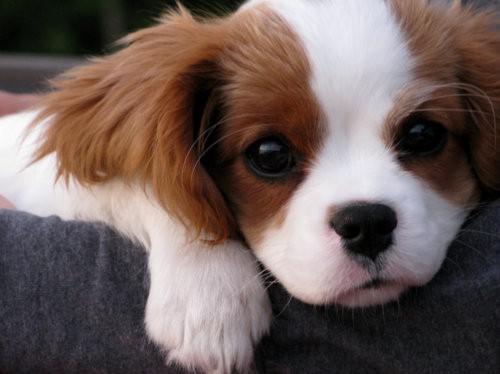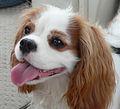The first image is the image on the left, the second image is the image on the right. Analyze the images presented: Is the assertion "In one image there is a dog laying down while looking towards the camera." valid? Answer yes or no. Yes. The first image is the image on the left, the second image is the image on the right. Assess this claim about the two images: "In one of the images, the puppy is lying down with its chin resting on something". Correct or not? Answer yes or no. Yes. 